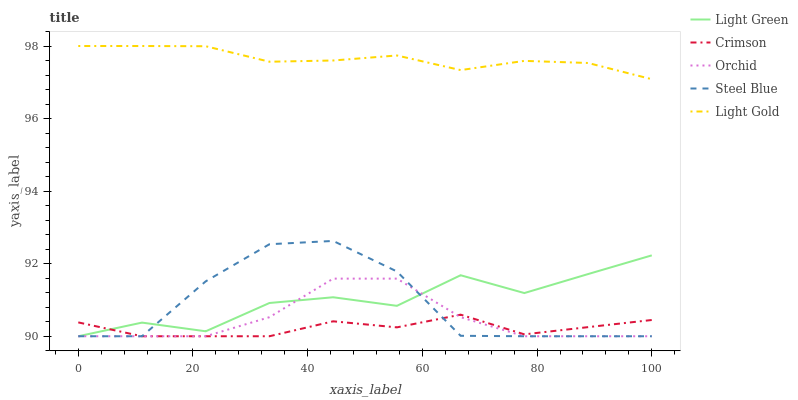Does Crimson have the minimum area under the curve?
Answer yes or no. Yes. Does Light Gold have the maximum area under the curve?
Answer yes or no. Yes. Does Steel Blue have the minimum area under the curve?
Answer yes or no. No. Does Steel Blue have the maximum area under the curve?
Answer yes or no. No. Is Light Gold the smoothest?
Answer yes or no. Yes. Is Steel Blue the roughest?
Answer yes or no. Yes. Is Steel Blue the smoothest?
Answer yes or no. No. Is Light Gold the roughest?
Answer yes or no. No. Does Light Gold have the lowest value?
Answer yes or no. No. Does Light Gold have the highest value?
Answer yes or no. Yes. Does Steel Blue have the highest value?
Answer yes or no. No. Is Light Green less than Light Gold?
Answer yes or no. Yes. Is Light Gold greater than Light Green?
Answer yes or no. Yes. Does Light Green intersect Crimson?
Answer yes or no. Yes. Is Light Green less than Crimson?
Answer yes or no. No. Is Light Green greater than Crimson?
Answer yes or no. No. Does Light Green intersect Light Gold?
Answer yes or no. No. 